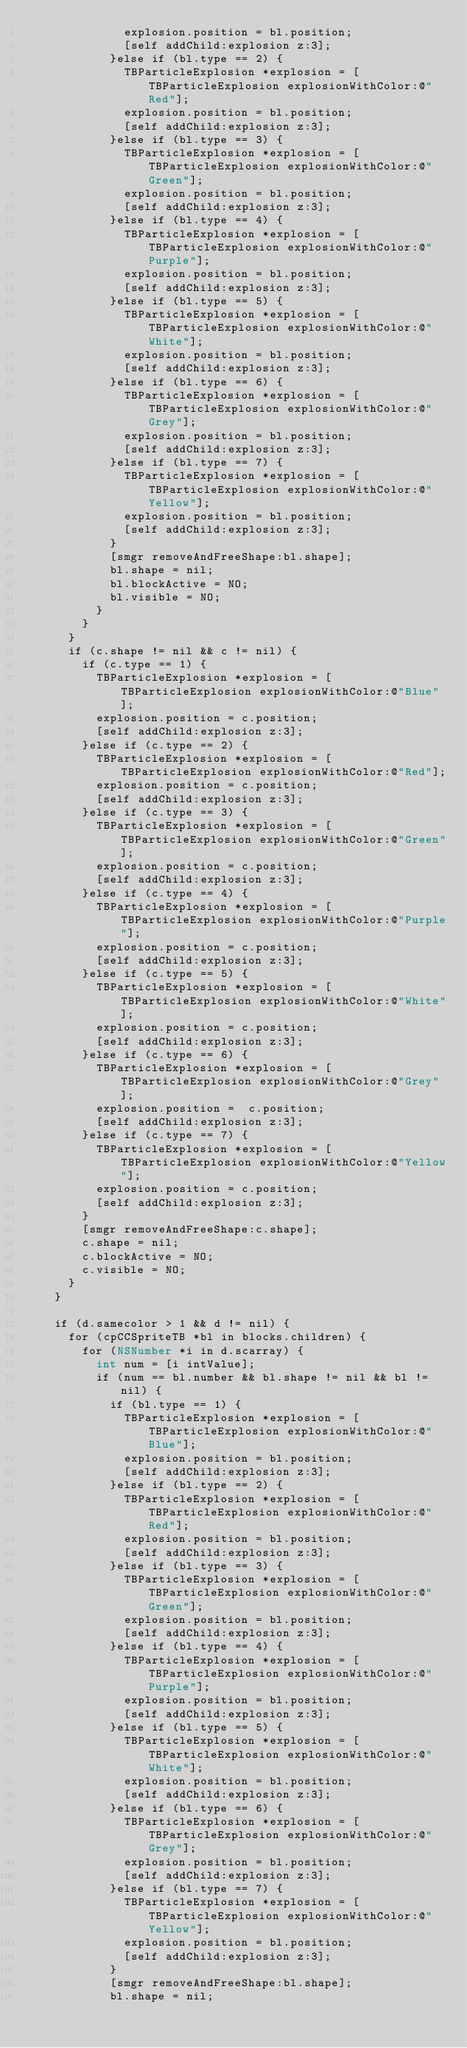<code> <loc_0><loc_0><loc_500><loc_500><_ObjectiveC_>							explosion.position = bl.position;
							[self addChild:explosion z:3];
						}else if (bl.type == 2) {
							TBParticleExplosion *explosion = [TBParticleExplosion explosionWithColor:@"Red"];
							explosion.position = bl.position;
							[self addChild:explosion z:3];
						}else if (bl.type == 3) {
							TBParticleExplosion *explosion = [TBParticleExplosion explosionWithColor:@"Green"];
							explosion.position = bl.position;
							[self addChild:explosion z:3];
						}else if (bl.type == 4) {
							TBParticleExplosion *explosion = [TBParticleExplosion explosionWithColor:@"Purple"];
							explosion.position = bl.position;
							[self addChild:explosion z:3];
						}else if (bl.type == 5) {
							TBParticleExplosion *explosion = [TBParticleExplosion explosionWithColor:@"White"];
							explosion.position = bl.position;
							[self addChild:explosion z:3];
						}else if (bl.type == 6) {
							TBParticleExplosion *explosion = [TBParticleExplosion explosionWithColor:@"Grey"];
							explosion.position = bl.position;
							[self addChild:explosion z:3];
						}else if (bl.type == 7) {
							TBParticleExplosion *explosion = [TBParticleExplosion explosionWithColor:@"Yellow"];
							explosion.position = bl.position;
							[self addChild:explosion z:3];
						}
						[smgr removeAndFreeShape:bl.shape];
						bl.shape = nil;
						bl.blockActive = NO;
						bl.visible = NO;
					}
				}
			}
			if (c.shape != nil && c != nil) {
				if (c.type == 1) {
					TBParticleExplosion *explosion = [TBParticleExplosion explosionWithColor:@"Blue"];
					explosion.position = c.position;
					[self addChild:explosion z:3];
				}else if (c.type == 2) {
					TBParticleExplosion *explosion = [TBParticleExplosion explosionWithColor:@"Red"];
					explosion.position = c.position;
					[self addChild:explosion z:3];
				}else if (c.type == 3) {
					TBParticleExplosion *explosion = [TBParticleExplosion explosionWithColor:@"Green"];
					explosion.position = c.position;
					[self addChild:explosion z:3];
				}else if (c.type == 4) {
					TBParticleExplosion *explosion = [TBParticleExplosion explosionWithColor:@"Purple"];
					explosion.position = c.position;
					[self addChild:explosion z:3];
				}else if (c.type == 5) {
					TBParticleExplosion *explosion = [TBParticleExplosion explosionWithColor:@"White"];
					explosion.position = c.position;
					[self addChild:explosion z:3];
				}else if (c.type == 6) {
					TBParticleExplosion *explosion = [TBParticleExplosion explosionWithColor:@"Grey"];
					explosion.position =  c.position;
					[self addChild:explosion z:3];
				}else if (c.type == 7) {
					TBParticleExplosion *explosion = [TBParticleExplosion explosionWithColor:@"Yellow"];
					explosion.position = c.position;
					[self addChild:explosion z:3];
				}	
				[smgr removeAndFreeShape:c.shape];
				c.shape = nil;
				c.blockActive = NO;
				c.visible = NO;
			}
		}
		
		if (d.samecolor > 1 && d != nil) {
			for (cpCCSpriteTB *bl in blocks.children) {
				for (NSNumber *i in d.scarray) {
					int num = [i intValue];
					if (num == bl.number && bl.shape != nil && bl != nil) {
						if (bl.type == 1) {
							TBParticleExplosion *explosion = [TBParticleExplosion explosionWithColor:@"Blue"];
							explosion.position = bl.position;
							[self addChild:explosion z:3];
						}else if (bl.type == 2) {
							TBParticleExplosion *explosion = [TBParticleExplosion explosionWithColor:@"Red"];
							explosion.position = bl.position;
							[self addChild:explosion z:3];
						}else if (bl.type == 3) {
							TBParticleExplosion *explosion = [TBParticleExplosion explosionWithColor:@"Green"];
							explosion.position = bl.position;
							[self addChild:explosion z:3];
						}else if (bl.type == 4) {
							TBParticleExplosion *explosion = [TBParticleExplosion explosionWithColor:@"Purple"];
							explosion.position = bl.position;
							[self addChild:explosion z:3];
						}else if (bl.type == 5) {
							TBParticleExplosion *explosion = [TBParticleExplosion explosionWithColor:@"White"];
							explosion.position = bl.position;
							[self addChild:explosion z:3];
						}else if (bl.type == 6) {
							TBParticleExplosion *explosion = [TBParticleExplosion explosionWithColor:@"Grey"];
							explosion.position = bl.position;
							[self addChild:explosion z:3];
						}else if (bl.type == 7) {
							TBParticleExplosion *explosion = [TBParticleExplosion explosionWithColor:@"Yellow"];
							explosion.position = bl.position;
							[self addChild:explosion z:3];
						}	
						[smgr removeAndFreeShape:bl.shape];
						bl.shape = nil;</code> 